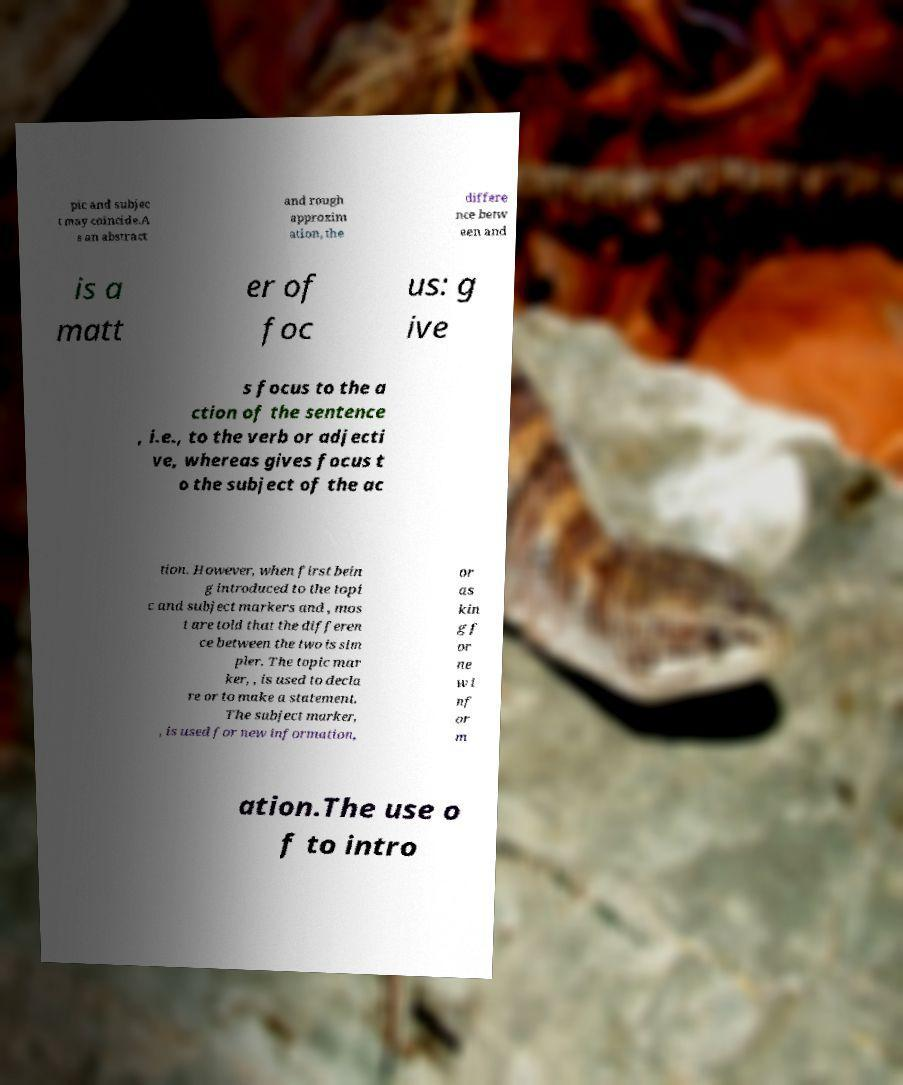Can you read and provide the text displayed in the image?This photo seems to have some interesting text. Can you extract and type it out for me? pic and subjec t may coincide.A s an abstract and rough approxim ation, the differe nce betw een and is a matt er of foc us: g ive s focus to the a ction of the sentence , i.e., to the verb or adjecti ve, whereas gives focus t o the subject of the ac tion. However, when first bein g introduced to the topi c and subject markers and , mos t are told that the differen ce between the two is sim pler. The topic mar ker, , is used to decla re or to make a statement. The subject marker, , is used for new information, or as kin g f or ne w i nf or m ation.The use o f to intro 